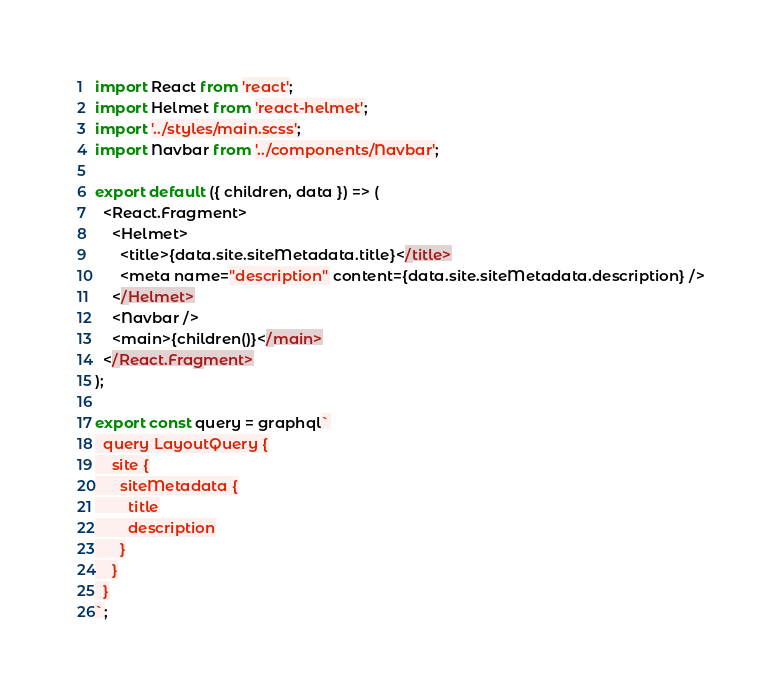<code> <loc_0><loc_0><loc_500><loc_500><_JavaScript_>import React from 'react';
import Helmet from 'react-helmet';
import '../styles/main.scss';
import Navbar from '../components/Navbar';

export default ({ children, data }) => (
  <React.Fragment>
    <Helmet>
      <title>{data.site.siteMetadata.title}</title>
      <meta name="description" content={data.site.siteMetadata.description} />
    </Helmet>
    <Navbar />
    <main>{children()}</main>
  </React.Fragment>
);

export const query = graphql`
  query LayoutQuery {
    site {
      siteMetadata {
        title
        description
      }
    }
  }
`;
</code> 